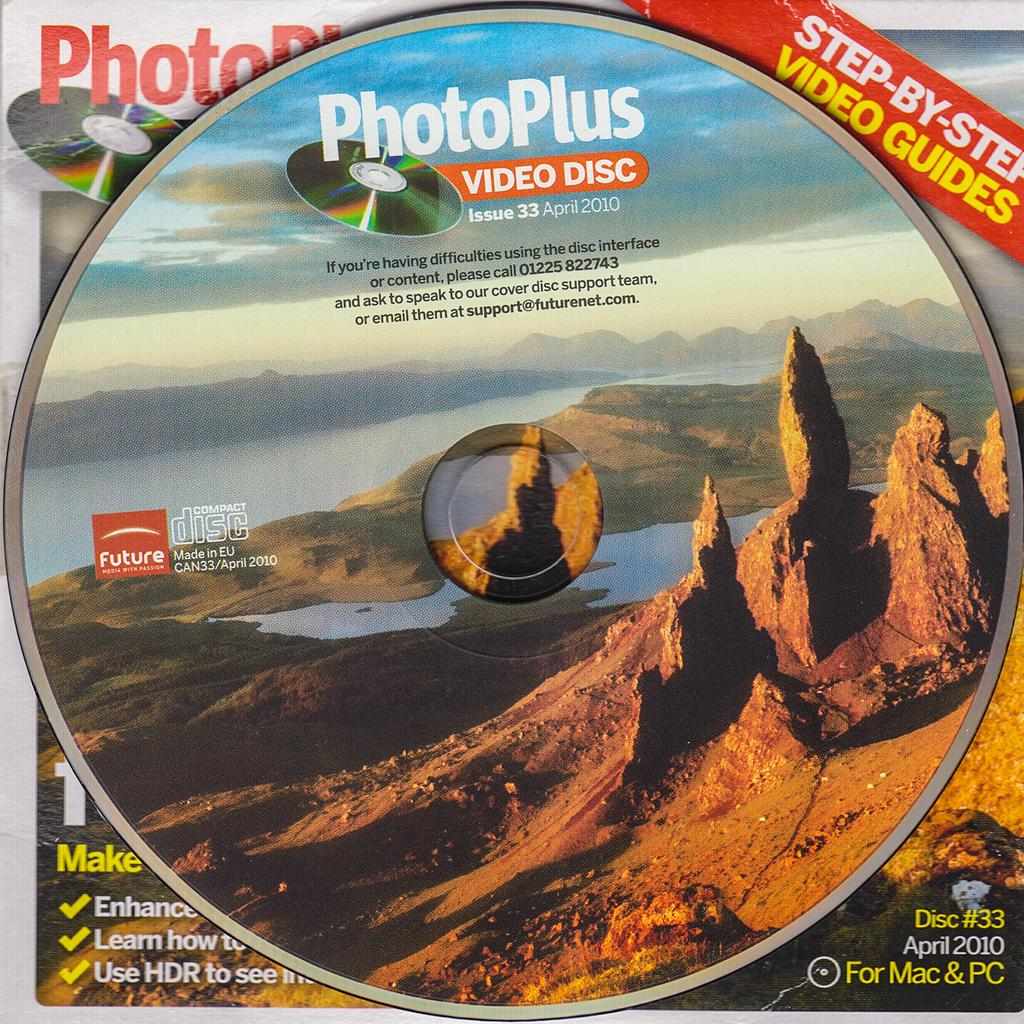<image>
Give a short and clear explanation of the subsequent image. A video disc from PhotoPlus has the date April 2010 on it. 